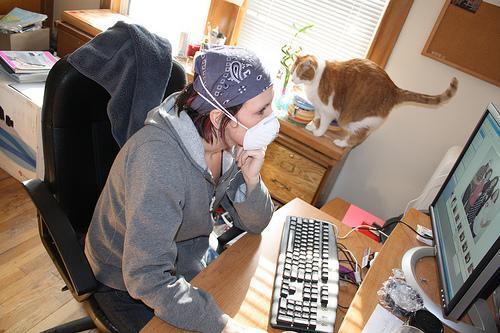How many cats are there?
Give a very brief answer. 1. How many people are in the picture?
Give a very brief answer. 1. 